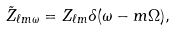<formula> <loc_0><loc_0><loc_500><loc_500>\tilde { Z } _ { \ell m \omega } = Z _ { \ell m } \delta ( \omega - m \Omega ) ,</formula> 